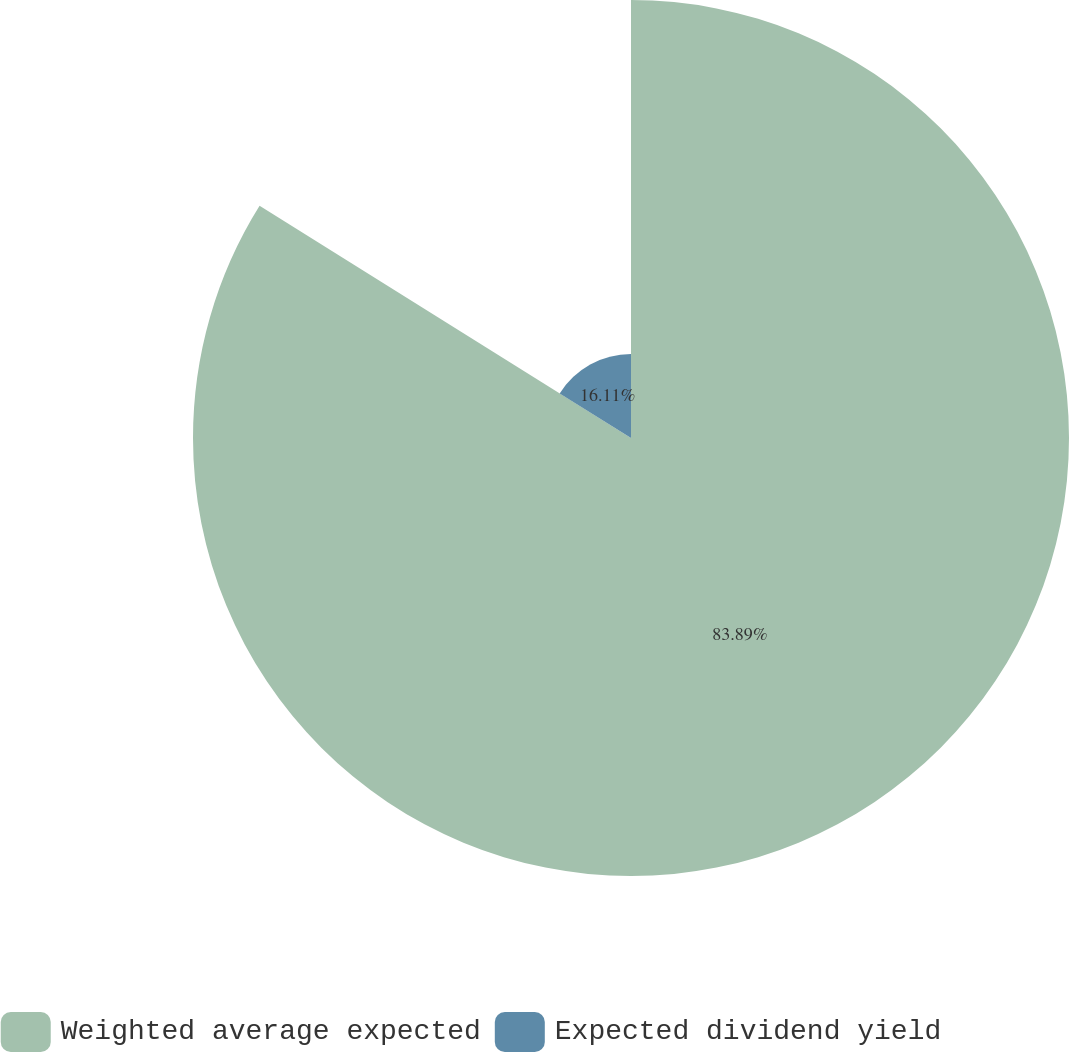Convert chart to OTSL. <chart><loc_0><loc_0><loc_500><loc_500><pie_chart><fcel>Weighted average expected<fcel>Expected dividend yield<nl><fcel>83.89%<fcel>16.11%<nl></chart> 